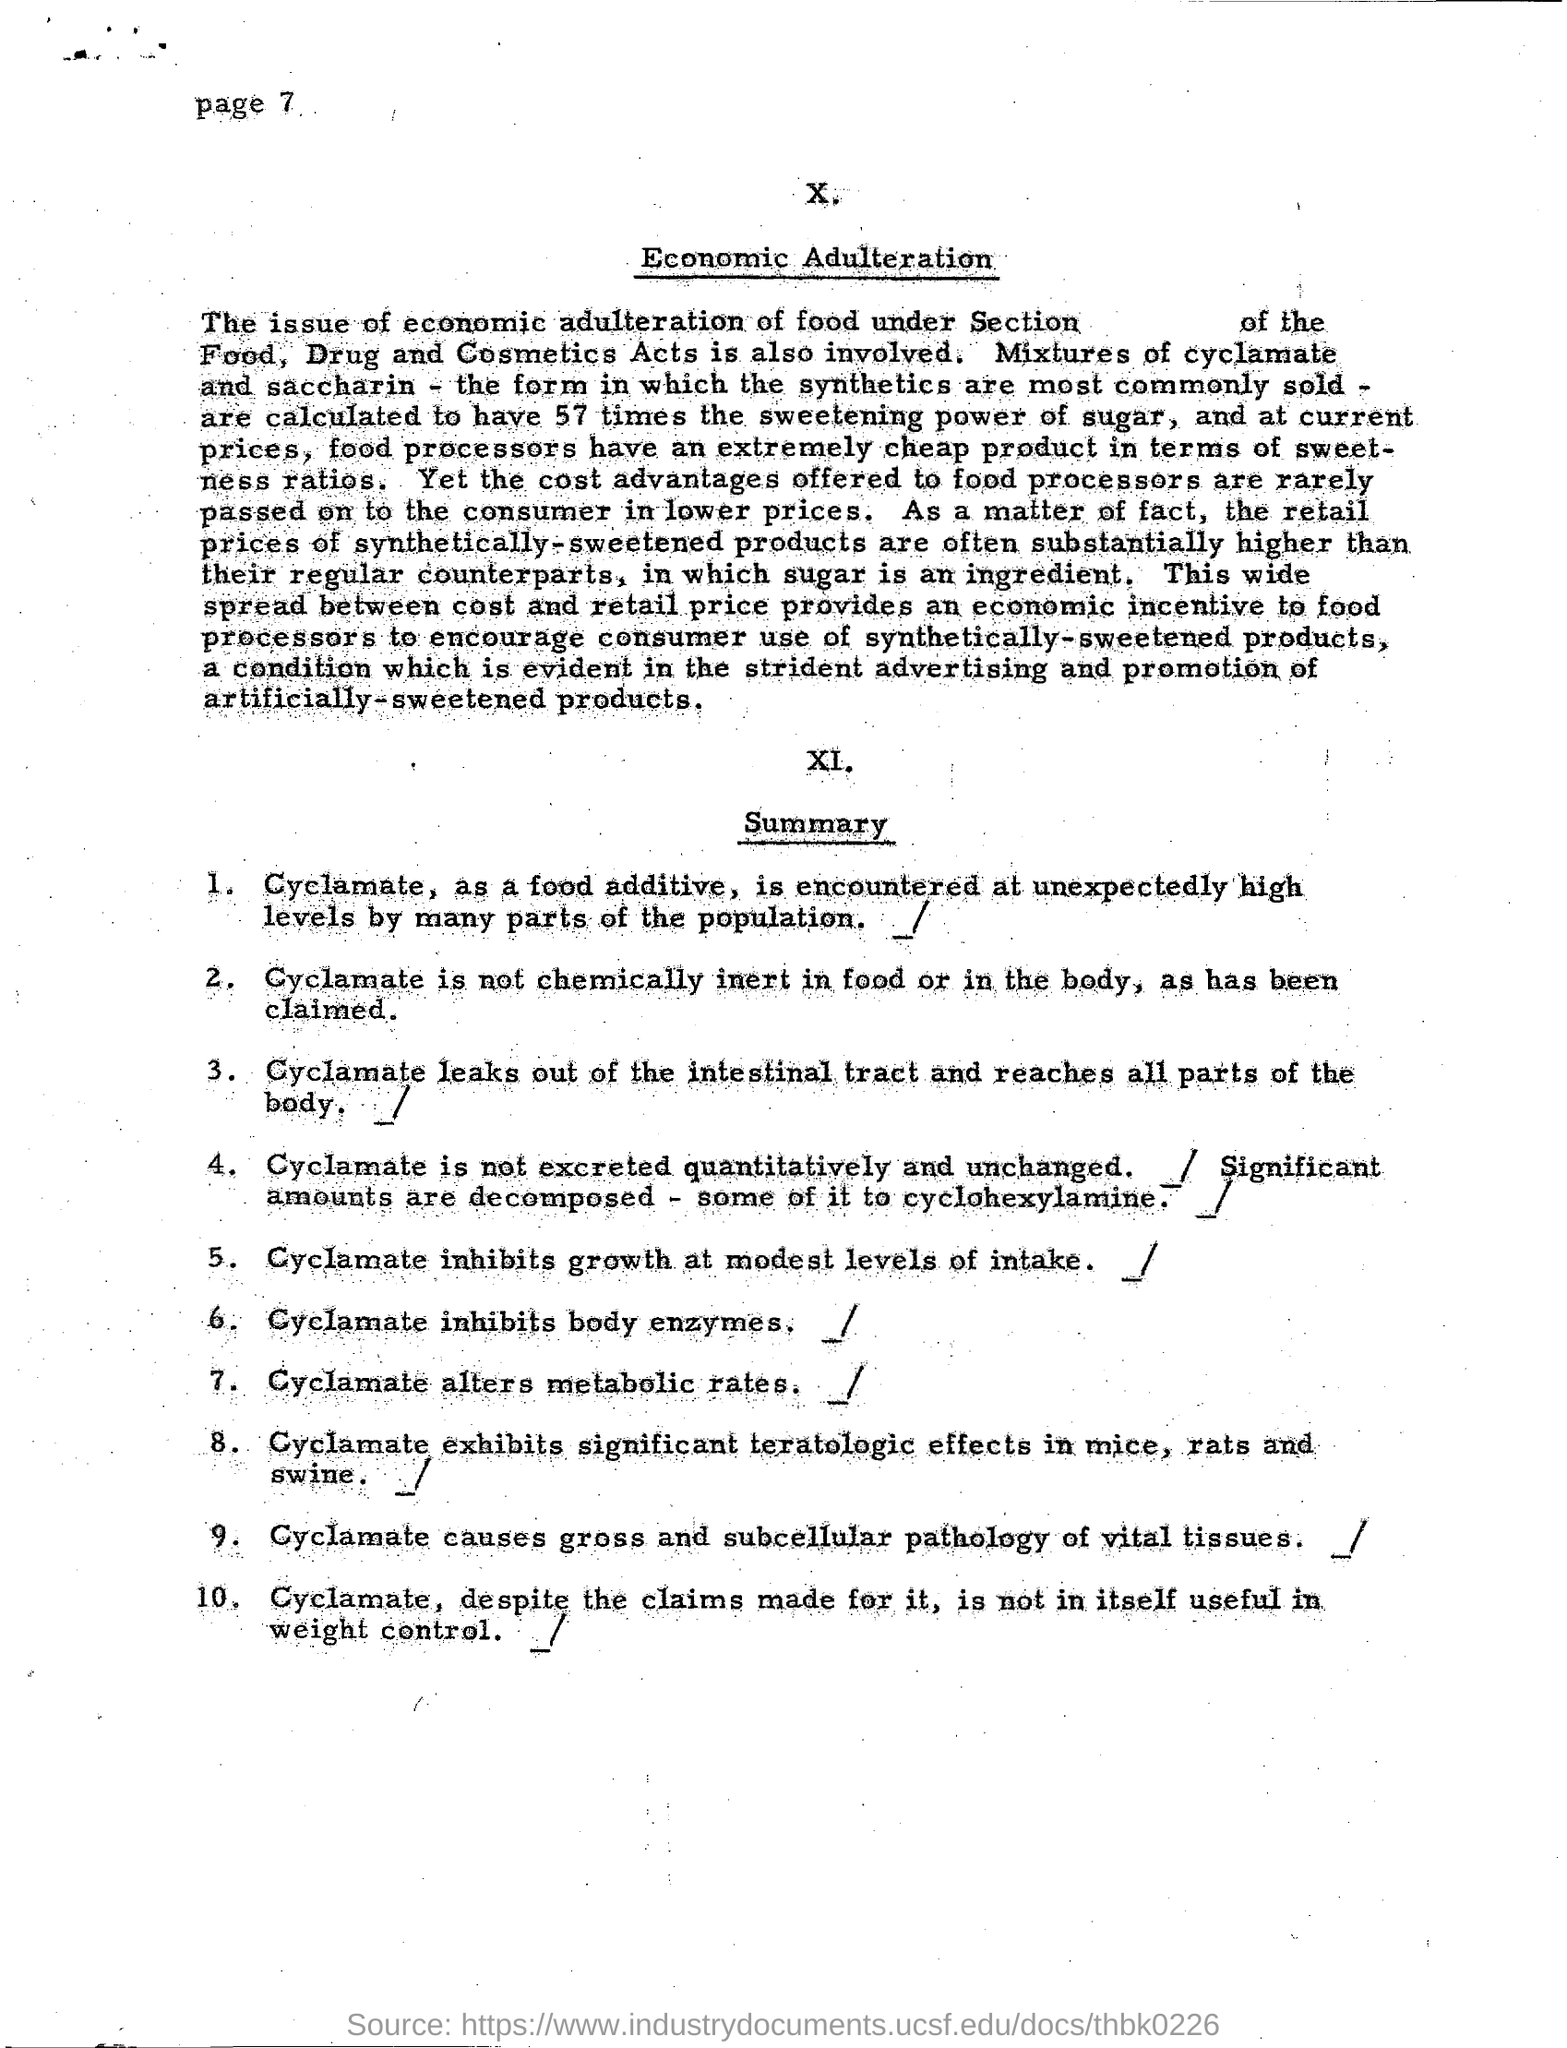What is encountered at unexpectedly high levels by many parts of population?
Your answer should be compact. Cyclamate. What inhibits body enzymes?
Offer a terse response. Cyclamate. What alters metabolic rates?
Give a very brief answer. Cyclamate. What inhibits growth at modest levels of intake?
Offer a very short reply. Cyclamate. 